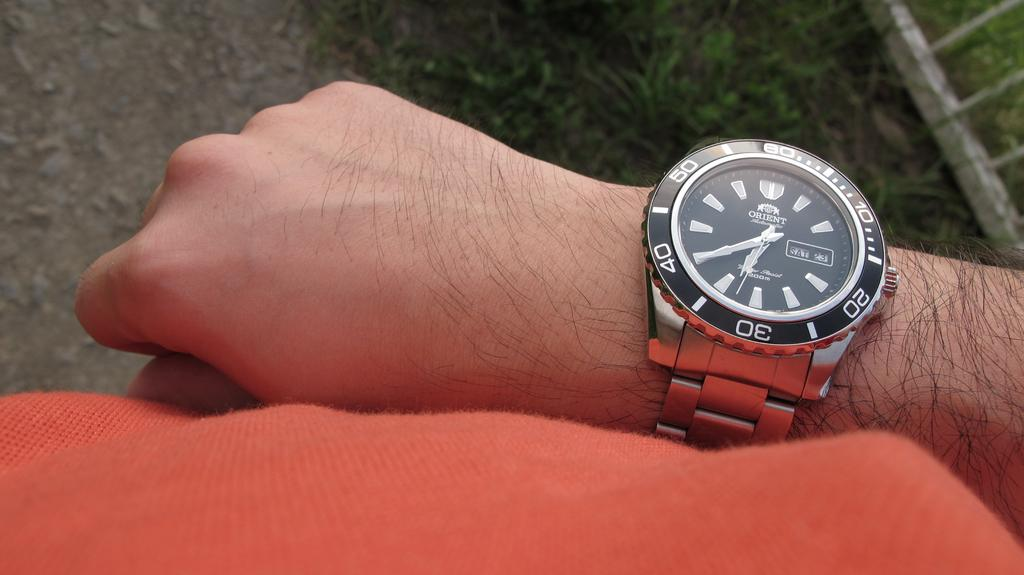<image>
Provide a brief description of the given image. A men's watch that is made by the brand Orient. 